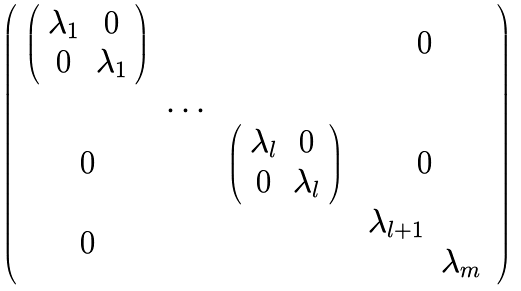<formula> <loc_0><loc_0><loc_500><loc_500>\left ( \begin{array} { c c c c c c } \left ( \begin{array} { c c } \lambda _ { 1 } & 0 \\ 0 & \lambda _ { 1 } \\ \end{array} \right ) & & & 0 \\ & \dots & \\ 0 & & \left ( \begin{array} { c c } \lambda _ { l } & 0 \\ 0 & \lambda _ { l } \\ \end{array} \right ) & 0 \\ 0 & & & \begin{array} { c c } \lambda _ { l + 1 } & \\ & \lambda _ { m } \\ \end{array} \\ \end{array} \right )</formula> 